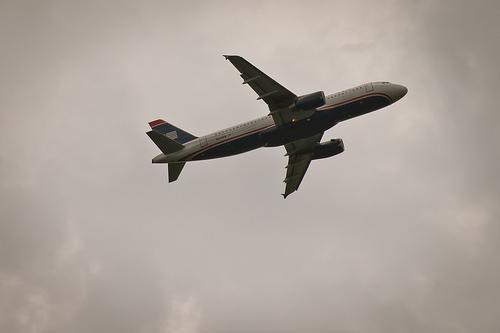How many planes in the photo?
Give a very brief answer. 1. 